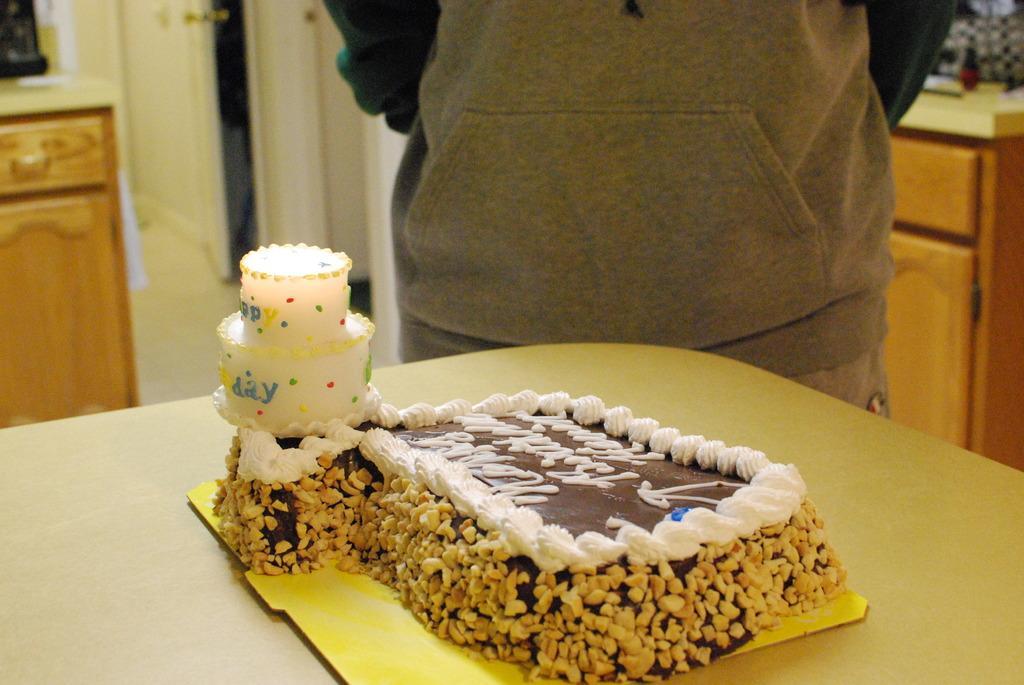Could you give a brief overview of what you see in this image? In this image we can see a table and on the table there is a cake. Beside the table we can see a person. 